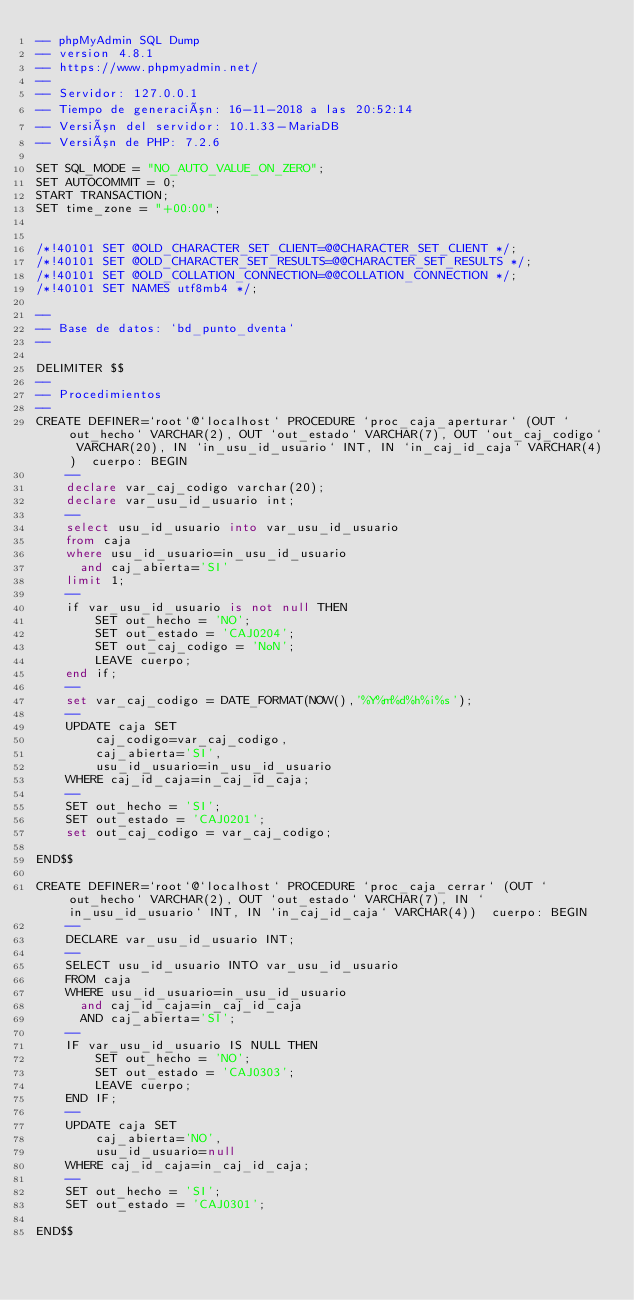<code> <loc_0><loc_0><loc_500><loc_500><_SQL_>-- phpMyAdmin SQL Dump
-- version 4.8.1
-- https://www.phpmyadmin.net/
--
-- Servidor: 127.0.0.1
-- Tiempo de generación: 16-11-2018 a las 20:52:14
-- Versión del servidor: 10.1.33-MariaDB
-- Versión de PHP: 7.2.6

SET SQL_MODE = "NO_AUTO_VALUE_ON_ZERO";
SET AUTOCOMMIT = 0;
START TRANSACTION;
SET time_zone = "+00:00";


/*!40101 SET @OLD_CHARACTER_SET_CLIENT=@@CHARACTER_SET_CLIENT */;
/*!40101 SET @OLD_CHARACTER_SET_RESULTS=@@CHARACTER_SET_RESULTS */;
/*!40101 SET @OLD_COLLATION_CONNECTION=@@COLLATION_CONNECTION */;
/*!40101 SET NAMES utf8mb4 */;

--
-- Base de datos: `bd_punto_dventa`
--

DELIMITER $$
--
-- Procedimientos
--
CREATE DEFINER=`root`@`localhost` PROCEDURE `proc_caja_aperturar` (OUT `out_hecho` VARCHAR(2), OUT `out_estado` VARCHAR(7), OUT `out_caj_codigo` VARCHAR(20), IN `in_usu_id_usuario` INT, IN `in_caj_id_caja` VARCHAR(4))  cuerpo: BEGIN
    -- 
    declare var_caj_codigo varchar(20);
    declare var_usu_id_usuario int;
    -- 
    select usu_id_usuario into var_usu_id_usuario
    from caja
    where usu_id_usuario=in_usu_id_usuario
      and caj_abierta='SI'
    limit 1;
    -- 
    if var_usu_id_usuario is not null THEN
        SET out_hecho = 'NO';
        SET out_estado = 'CAJ0204';
        SET out_caj_codigo = 'NoN';
        LEAVE cuerpo;
    end if;
    -- 
    set var_caj_codigo = DATE_FORMAT(NOW(),'%Y%m%d%h%i%s');
    -- 
    UPDATE caja SET
        caj_codigo=var_caj_codigo,
        caj_abierta='SI',
        usu_id_usuario=in_usu_id_usuario
    WHERE caj_id_caja=in_caj_id_caja;
    -- 
    SET out_hecho = 'SI';
    SET out_estado = 'CAJ0201';
    set out_caj_codigo = var_caj_codigo;
    
END$$

CREATE DEFINER=`root`@`localhost` PROCEDURE `proc_caja_cerrar` (OUT `out_hecho` VARCHAR(2), OUT `out_estado` VARCHAR(7), IN `in_usu_id_usuario` INT, IN `in_caj_id_caja` VARCHAR(4))  cuerpo: BEGIN
    -- 
    DECLARE var_usu_id_usuario INT;
    -- 
    SELECT usu_id_usuario INTO var_usu_id_usuario
    FROM caja
    WHERE usu_id_usuario=in_usu_id_usuario
      and caj_id_caja=in_caj_id_caja
      AND caj_abierta='SI';
    -- 
    IF var_usu_id_usuario IS NULL THEN
        SET out_hecho = 'NO';
        SET out_estado = 'CAJ0303';
        LEAVE cuerpo;
    END IF;
    -- 
    UPDATE caja SET
        caj_abierta='NO',
        usu_id_usuario=null
    WHERE caj_id_caja=in_caj_id_caja;
    -- 
    SET out_hecho = 'SI';
    SET out_estado = 'CAJ0301';
    
END$$
</code> 